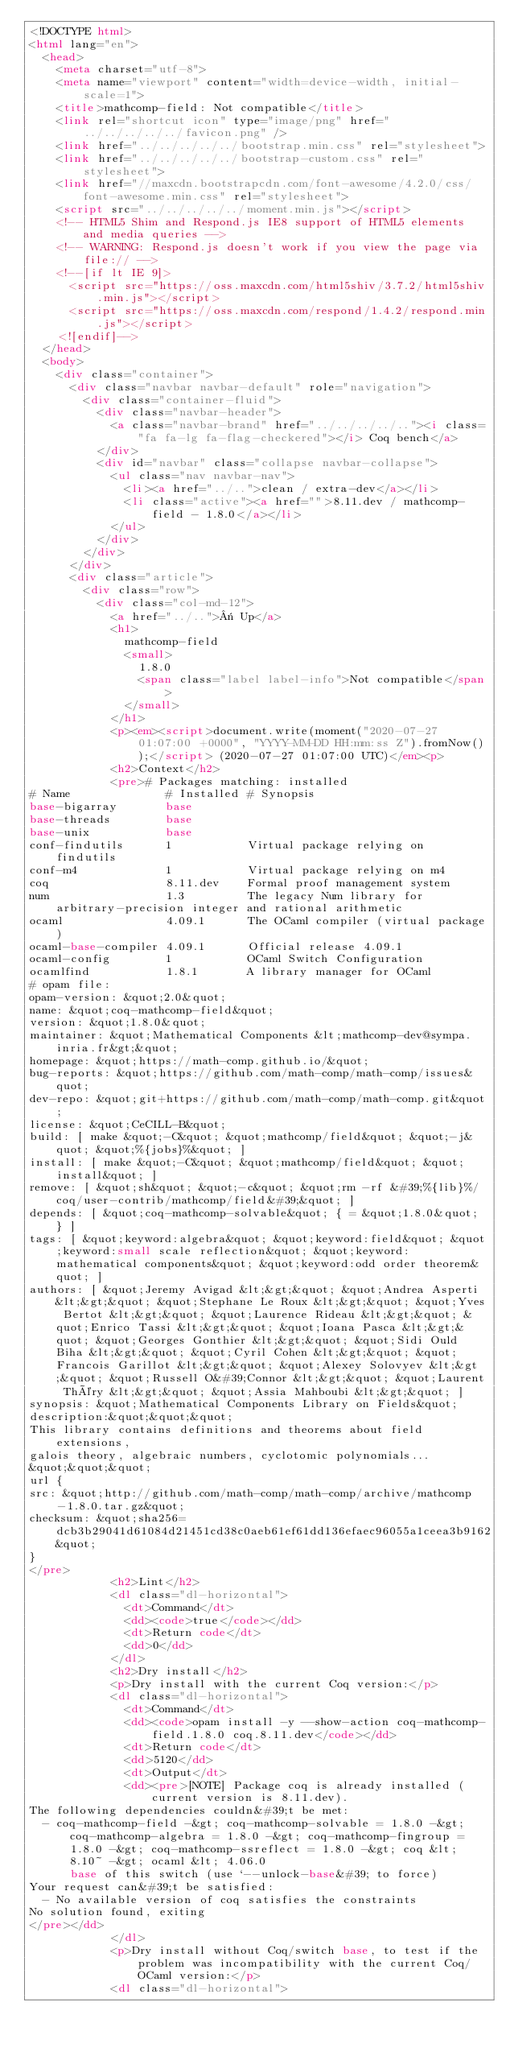<code> <loc_0><loc_0><loc_500><loc_500><_HTML_><!DOCTYPE html>
<html lang="en">
  <head>
    <meta charset="utf-8">
    <meta name="viewport" content="width=device-width, initial-scale=1">
    <title>mathcomp-field: Not compatible</title>
    <link rel="shortcut icon" type="image/png" href="../../../../../favicon.png" />
    <link href="../../../../../bootstrap.min.css" rel="stylesheet">
    <link href="../../../../../bootstrap-custom.css" rel="stylesheet">
    <link href="//maxcdn.bootstrapcdn.com/font-awesome/4.2.0/css/font-awesome.min.css" rel="stylesheet">
    <script src="../../../../../moment.min.js"></script>
    <!-- HTML5 Shim and Respond.js IE8 support of HTML5 elements and media queries -->
    <!-- WARNING: Respond.js doesn't work if you view the page via file:// -->
    <!--[if lt IE 9]>
      <script src="https://oss.maxcdn.com/html5shiv/3.7.2/html5shiv.min.js"></script>
      <script src="https://oss.maxcdn.com/respond/1.4.2/respond.min.js"></script>
    <![endif]-->
  </head>
  <body>
    <div class="container">
      <div class="navbar navbar-default" role="navigation">
        <div class="container-fluid">
          <div class="navbar-header">
            <a class="navbar-brand" href="../../../../.."><i class="fa fa-lg fa-flag-checkered"></i> Coq bench</a>
          </div>
          <div id="navbar" class="collapse navbar-collapse">
            <ul class="nav navbar-nav">
              <li><a href="../..">clean / extra-dev</a></li>
              <li class="active"><a href="">8.11.dev / mathcomp-field - 1.8.0</a></li>
            </ul>
          </div>
        </div>
      </div>
      <div class="article">
        <div class="row">
          <div class="col-md-12">
            <a href="../..">« Up</a>
            <h1>
              mathcomp-field
              <small>
                1.8.0
                <span class="label label-info">Not compatible</span>
              </small>
            </h1>
            <p><em><script>document.write(moment("2020-07-27 01:07:00 +0000", "YYYY-MM-DD HH:mm:ss Z").fromNow());</script> (2020-07-27 01:07:00 UTC)</em><p>
            <h2>Context</h2>
            <pre># Packages matching: installed
# Name              # Installed # Synopsis
base-bigarray       base
base-threads        base
base-unix           base
conf-findutils      1           Virtual package relying on findutils
conf-m4             1           Virtual package relying on m4
coq                 8.11.dev    Formal proof management system
num                 1.3         The legacy Num library for arbitrary-precision integer and rational arithmetic
ocaml               4.09.1      The OCaml compiler (virtual package)
ocaml-base-compiler 4.09.1      Official release 4.09.1
ocaml-config        1           OCaml Switch Configuration
ocamlfind           1.8.1       A library manager for OCaml
# opam file:
opam-version: &quot;2.0&quot;
name: &quot;coq-mathcomp-field&quot;
version: &quot;1.8.0&quot;
maintainer: &quot;Mathematical Components &lt;mathcomp-dev@sympa.inria.fr&gt;&quot;
homepage: &quot;https://math-comp.github.io/&quot;
bug-reports: &quot;https://github.com/math-comp/math-comp/issues&quot;
dev-repo: &quot;git+https://github.com/math-comp/math-comp.git&quot;
license: &quot;CeCILL-B&quot;
build: [ make &quot;-C&quot; &quot;mathcomp/field&quot; &quot;-j&quot; &quot;%{jobs}%&quot; ]
install: [ make &quot;-C&quot; &quot;mathcomp/field&quot; &quot;install&quot; ]
remove: [ &quot;sh&quot; &quot;-c&quot; &quot;rm -rf &#39;%{lib}%/coq/user-contrib/mathcomp/field&#39;&quot; ]
depends: [ &quot;coq-mathcomp-solvable&quot; { = &quot;1.8.0&quot; } ]
tags: [ &quot;keyword:algebra&quot; &quot;keyword:field&quot; &quot;keyword:small scale reflection&quot; &quot;keyword:mathematical components&quot; &quot;keyword:odd order theorem&quot; ]
authors: [ &quot;Jeremy Avigad &lt;&gt;&quot; &quot;Andrea Asperti &lt;&gt;&quot; &quot;Stephane Le Roux &lt;&gt;&quot; &quot;Yves Bertot &lt;&gt;&quot; &quot;Laurence Rideau &lt;&gt;&quot; &quot;Enrico Tassi &lt;&gt;&quot; &quot;Ioana Pasca &lt;&gt;&quot; &quot;Georges Gonthier &lt;&gt;&quot; &quot;Sidi Ould Biha &lt;&gt;&quot; &quot;Cyril Cohen &lt;&gt;&quot; &quot;Francois Garillot &lt;&gt;&quot; &quot;Alexey Solovyev &lt;&gt;&quot; &quot;Russell O&#39;Connor &lt;&gt;&quot; &quot;Laurent Théry &lt;&gt;&quot; &quot;Assia Mahboubi &lt;&gt;&quot; ]
synopsis: &quot;Mathematical Components Library on Fields&quot;
description:&quot;&quot;&quot;
This library contains definitions and theorems about field extensions,
galois theory, algebraic numbers, cyclotomic polynomials...
&quot;&quot;&quot;
url {
src: &quot;http://github.com/math-comp/math-comp/archive/mathcomp-1.8.0.tar.gz&quot;
checksum: &quot;sha256=dcb3b29041d61084d21451cd38c0aeb61ef61dd136efaec96055a1ceea3b9162&quot;
}
</pre>
            <h2>Lint</h2>
            <dl class="dl-horizontal">
              <dt>Command</dt>
              <dd><code>true</code></dd>
              <dt>Return code</dt>
              <dd>0</dd>
            </dl>
            <h2>Dry install</h2>
            <p>Dry install with the current Coq version:</p>
            <dl class="dl-horizontal">
              <dt>Command</dt>
              <dd><code>opam install -y --show-action coq-mathcomp-field.1.8.0 coq.8.11.dev</code></dd>
              <dt>Return code</dt>
              <dd>5120</dd>
              <dt>Output</dt>
              <dd><pre>[NOTE] Package coq is already installed (current version is 8.11.dev).
The following dependencies couldn&#39;t be met:
  - coq-mathcomp-field -&gt; coq-mathcomp-solvable = 1.8.0 -&gt; coq-mathcomp-algebra = 1.8.0 -&gt; coq-mathcomp-fingroup = 1.8.0 -&gt; coq-mathcomp-ssreflect = 1.8.0 -&gt; coq &lt; 8.10~ -&gt; ocaml &lt; 4.06.0
      base of this switch (use `--unlock-base&#39; to force)
Your request can&#39;t be satisfied:
  - No available version of coq satisfies the constraints
No solution found, exiting
</pre></dd>
            </dl>
            <p>Dry install without Coq/switch base, to test if the problem was incompatibility with the current Coq/OCaml version:</p>
            <dl class="dl-horizontal"></code> 